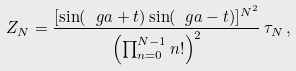Convert formula to latex. <formula><loc_0><loc_0><loc_500><loc_500>Z _ { N } = \frac { [ \sin ( \ g a + t ) \sin ( \ g a - t ) ] ^ { N ^ { 2 } } } { \left ( \prod _ { n = 0 } ^ { N - 1 } n ! \right ) ^ { 2 } } \, \tau _ { N } \, ,</formula> 